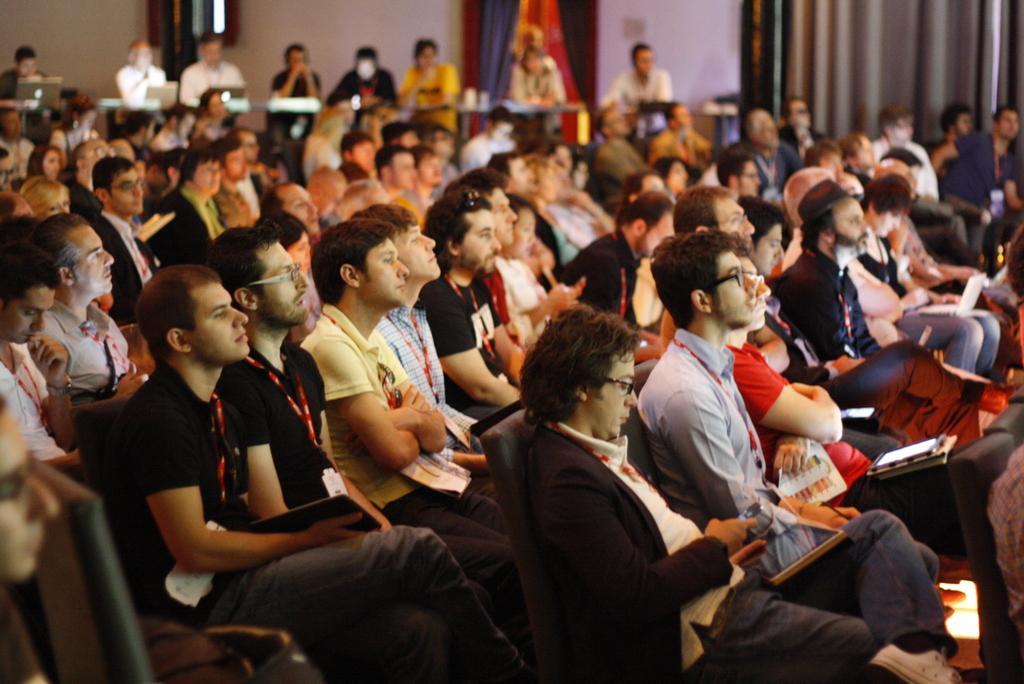Describe this image in one or two sentences. In this picture we can see many people sitting on chairs and looking at something. 